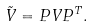Convert formula to latex. <formula><loc_0><loc_0><loc_500><loc_500>\tilde { V } & = P V P ^ { T } .</formula> 